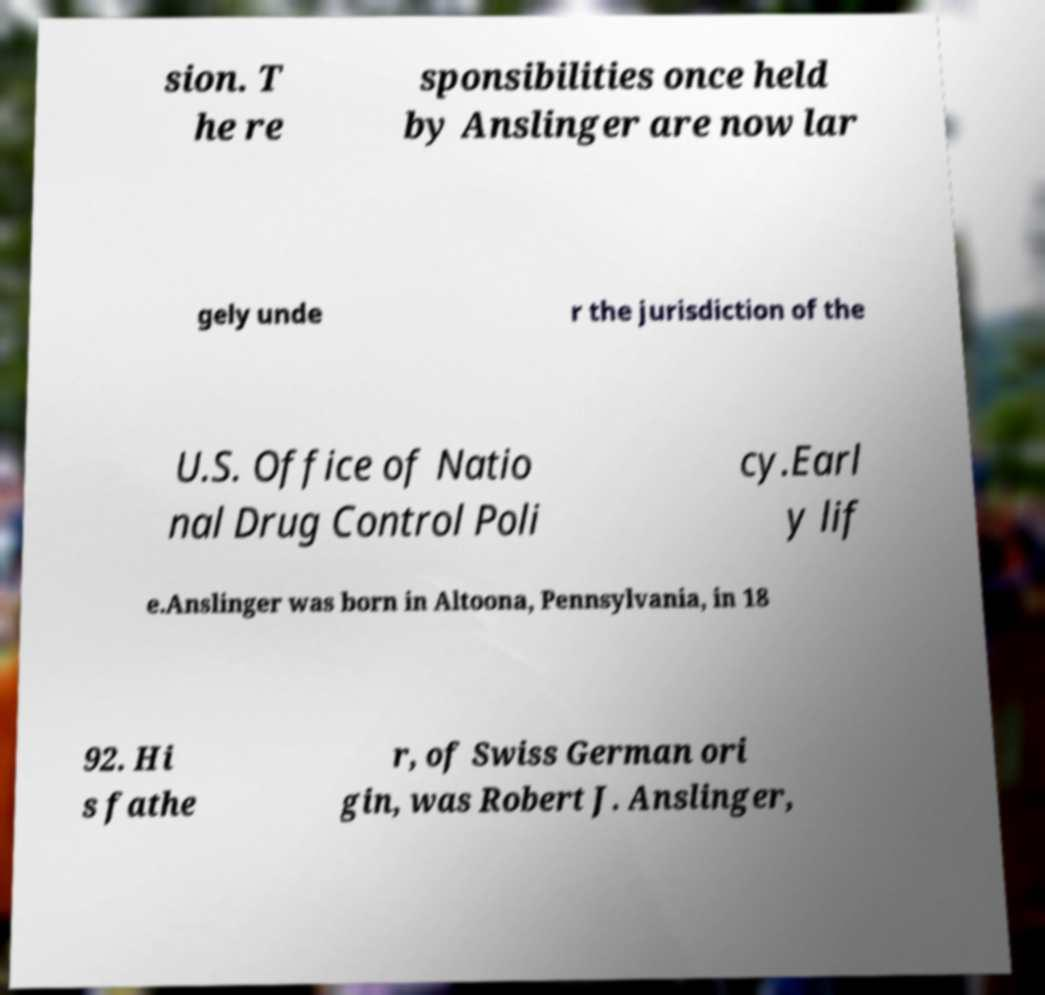Could you assist in decoding the text presented in this image and type it out clearly? sion. T he re sponsibilities once held by Anslinger are now lar gely unde r the jurisdiction of the U.S. Office of Natio nal Drug Control Poli cy.Earl y lif e.Anslinger was born in Altoona, Pennsylvania, in 18 92. Hi s fathe r, of Swiss German ori gin, was Robert J. Anslinger, 